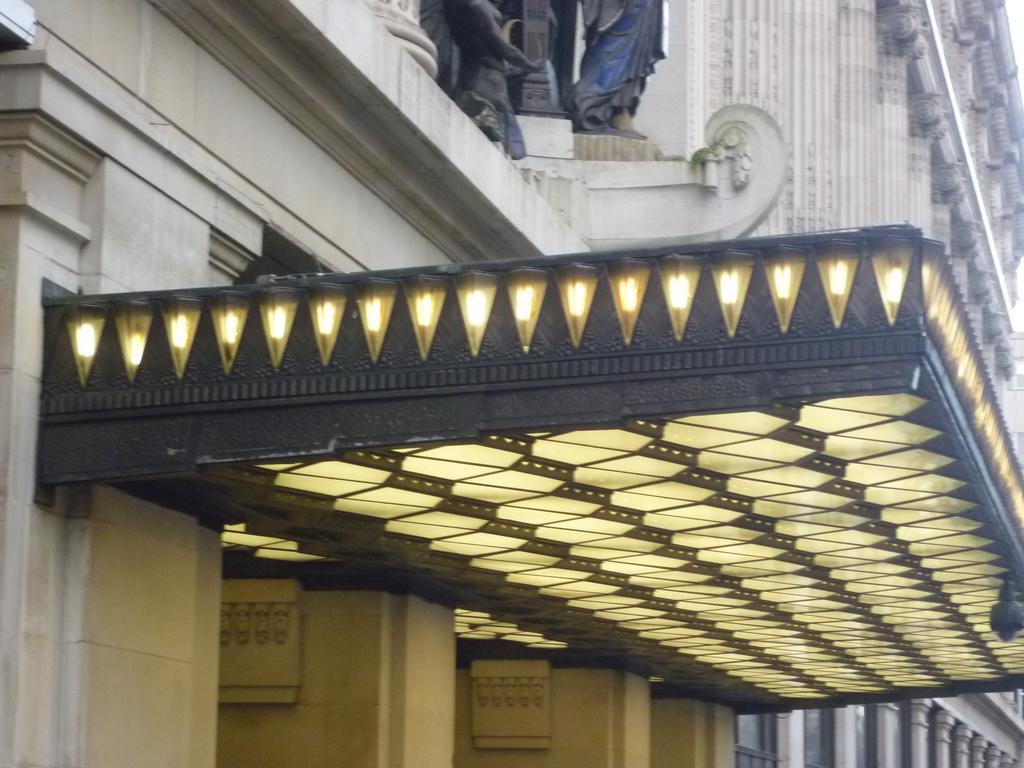Describe this image in one or two sentences. In this image I see a building which is of white in color and I see sculptures over here which are of black in color and I see the lights over here. 